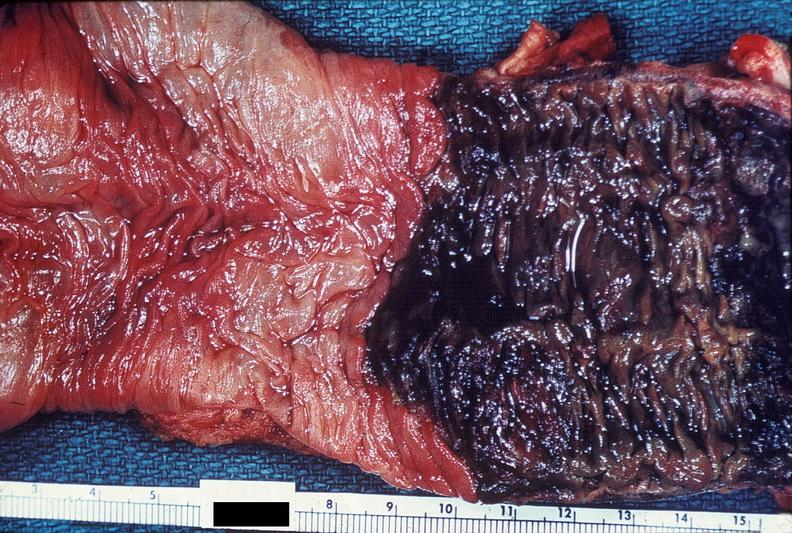what is present?
Answer the question using a single word or phrase. Gastrointestinal 